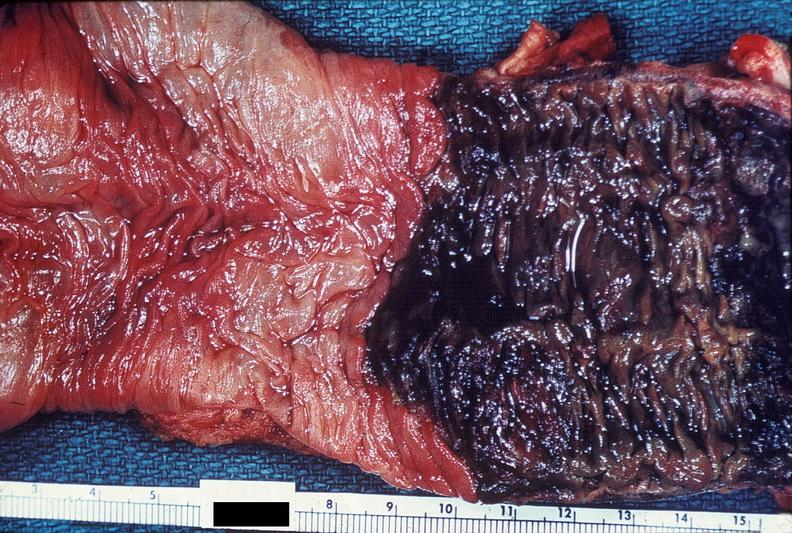what is present?
Answer the question using a single word or phrase. Gastrointestinal 